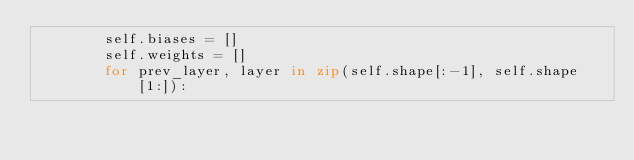<code> <loc_0><loc_0><loc_500><loc_500><_Python_>        self.biases = []
        self.weights = []
        for prev_layer, layer in zip(self.shape[:-1], self.shape[1:]):</code> 